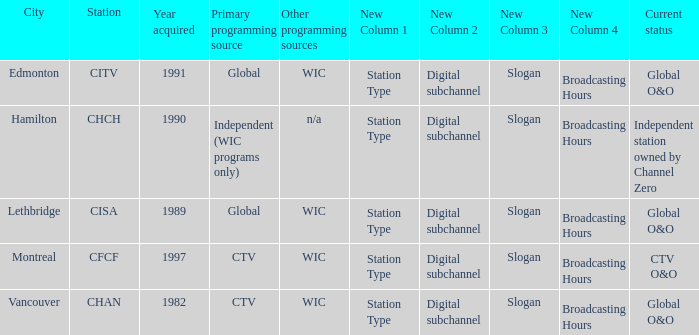How any were gained as the chan 1.0. 